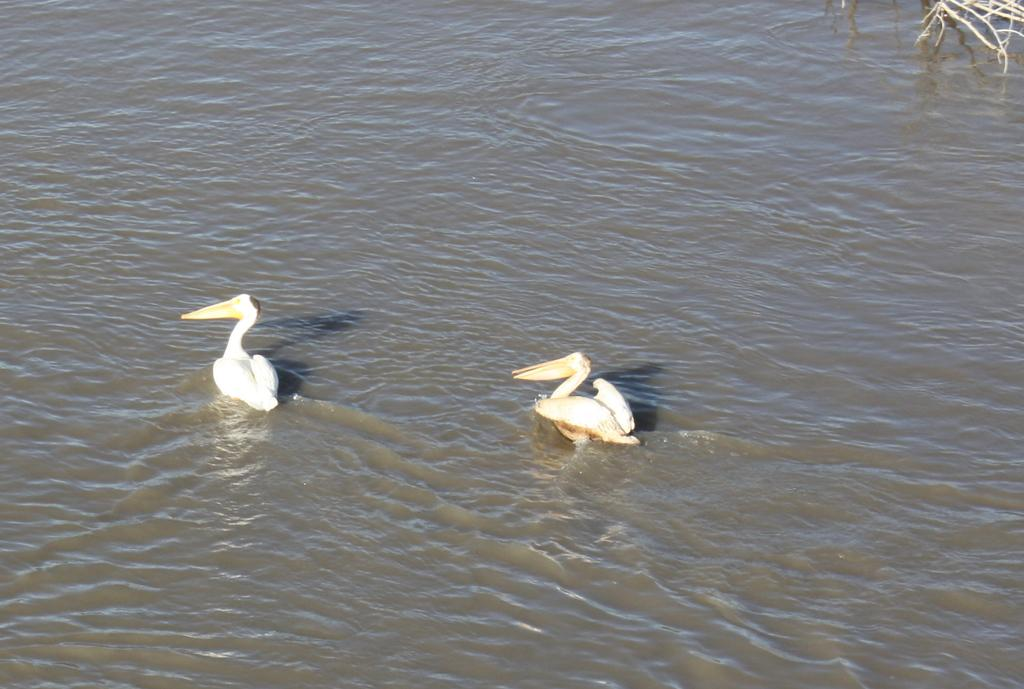How many birds are in the image? There are two birds in the image. Where are the birds located? The birds are on the water. What else can be seen in the image? There are wooden sticks visible in the top right corner of the image. What type of boot can be seen in the image? There is no boot present in the image. What season is depicted in the image? The image does not provide any information about the season, as it only shows two birds on the water and wooden sticks in the top right corner. 